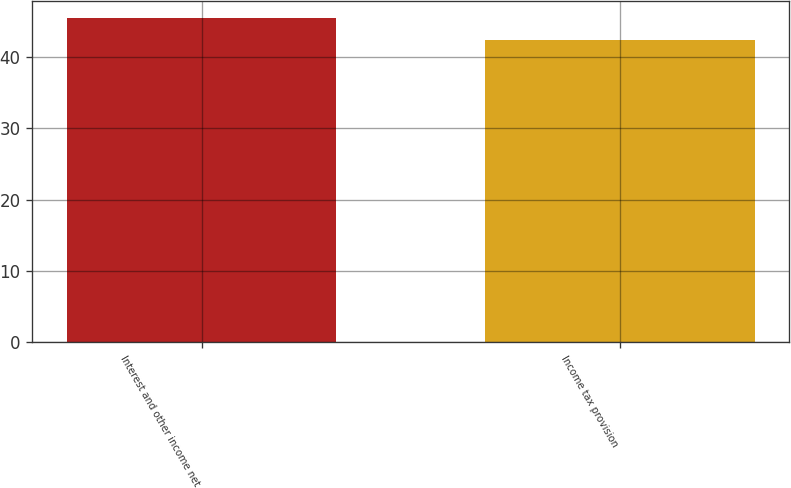Convert chart. <chart><loc_0><loc_0><loc_500><loc_500><bar_chart><fcel>Interest and other income net<fcel>Income tax provision<nl><fcel>45.5<fcel>42.4<nl></chart> 